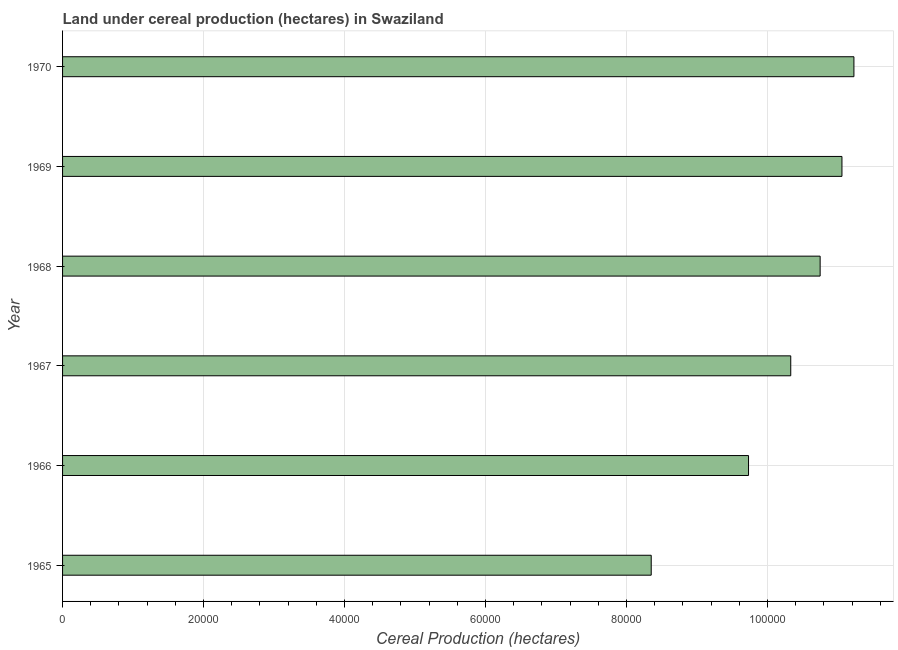Does the graph contain any zero values?
Make the answer very short. No. What is the title of the graph?
Your answer should be very brief. Land under cereal production (hectares) in Swaziland. What is the label or title of the X-axis?
Ensure brevity in your answer.  Cereal Production (hectares). What is the land under cereal production in 1965?
Your answer should be very brief. 8.35e+04. Across all years, what is the maximum land under cereal production?
Offer a terse response. 1.12e+05. Across all years, what is the minimum land under cereal production?
Offer a terse response. 8.35e+04. In which year was the land under cereal production maximum?
Provide a short and direct response. 1970. In which year was the land under cereal production minimum?
Ensure brevity in your answer.  1965. What is the sum of the land under cereal production?
Provide a succinct answer. 6.14e+05. What is the difference between the land under cereal production in 1968 and 1970?
Offer a very short reply. -4792. What is the average land under cereal production per year?
Offer a very short reply. 1.02e+05. What is the median land under cereal production?
Make the answer very short. 1.05e+05. In how many years, is the land under cereal production greater than 68000 hectares?
Your response must be concise. 6. Do a majority of the years between 1965 and 1970 (inclusive) have land under cereal production greater than 56000 hectares?
Offer a terse response. Yes. What is the ratio of the land under cereal production in 1966 to that in 1970?
Provide a succinct answer. 0.87. What is the difference between the highest and the second highest land under cereal production?
Give a very brief answer. 1698. What is the difference between the highest and the lowest land under cereal production?
Your answer should be compact. 2.88e+04. In how many years, is the land under cereal production greater than the average land under cereal production taken over all years?
Your answer should be very brief. 4. How many years are there in the graph?
Your response must be concise. 6. What is the Cereal Production (hectares) of 1965?
Your response must be concise. 8.35e+04. What is the Cereal Production (hectares) of 1966?
Your answer should be compact. 9.73e+04. What is the Cereal Production (hectares) in 1967?
Provide a short and direct response. 1.03e+05. What is the Cereal Production (hectares) in 1968?
Offer a very short reply. 1.07e+05. What is the Cereal Production (hectares) of 1969?
Give a very brief answer. 1.11e+05. What is the Cereal Production (hectares) in 1970?
Your answer should be compact. 1.12e+05. What is the difference between the Cereal Production (hectares) in 1965 and 1966?
Keep it short and to the point. -1.38e+04. What is the difference between the Cereal Production (hectares) in 1965 and 1967?
Make the answer very short. -1.98e+04. What is the difference between the Cereal Production (hectares) in 1965 and 1968?
Provide a succinct answer. -2.40e+04. What is the difference between the Cereal Production (hectares) in 1965 and 1969?
Provide a succinct answer. -2.71e+04. What is the difference between the Cereal Production (hectares) in 1965 and 1970?
Make the answer very short. -2.88e+04. What is the difference between the Cereal Production (hectares) in 1966 and 1967?
Provide a succinct answer. -5987. What is the difference between the Cereal Production (hectares) in 1966 and 1968?
Ensure brevity in your answer.  -1.02e+04. What is the difference between the Cereal Production (hectares) in 1966 and 1969?
Give a very brief answer. -1.33e+04. What is the difference between the Cereal Production (hectares) in 1966 and 1970?
Provide a short and direct response. -1.50e+04. What is the difference between the Cereal Production (hectares) in 1967 and 1968?
Keep it short and to the point. -4171. What is the difference between the Cereal Production (hectares) in 1967 and 1969?
Make the answer very short. -7265. What is the difference between the Cereal Production (hectares) in 1967 and 1970?
Your answer should be compact. -8963. What is the difference between the Cereal Production (hectares) in 1968 and 1969?
Your response must be concise. -3094. What is the difference between the Cereal Production (hectares) in 1968 and 1970?
Ensure brevity in your answer.  -4792. What is the difference between the Cereal Production (hectares) in 1969 and 1970?
Your answer should be very brief. -1698. What is the ratio of the Cereal Production (hectares) in 1965 to that in 1966?
Ensure brevity in your answer.  0.86. What is the ratio of the Cereal Production (hectares) in 1965 to that in 1967?
Ensure brevity in your answer.  0.81. What is the ratio of the Cereal Production (hectares) in 1965 to that in 1968?
Ensure brevity in your answer.  0.78. What is the ratio of the Cereal Production (hectares) in 1965 to that in 1969?
Your answer should be very brief. 0.76. What is the ratio of the Cereal Production (hectares) in 1965 to that in 1970?
Keep it short and to the point. 0.74. What is the ratio of the Cereal Production (hectares) in 1966 to that in 1967?
Your answer should be very brief. 0.94. What is the ratio of the Cereal Production (hectares) in 1966 to that in 1968?
Give a very brief answer. 0.91. What is the ratio of the Cereal Production (hectares) in 1966 to that in 1969?
Your answer should be compact. 0.88. What is the ratio of the Cereal Production (hectares) in 1966 to that in 1970?
Your answer should be very brief. 0.87. What is the ratio of the Cereal Production (hectares) in 1967 to that in 1969?
Offer a terse response. 0.93. What is the ratio of the Cereal Production (hectares) in 1968 to that in 1969?
Offer a very short reply. 0.97. What is the ratio of the Cereal Production (hectares) in 1968 to that in 1970?
Provide a short and direct response. 0.96. What is the ratio of the Cereal Production (hectares) in 1969 to that in 1970?
Your response must be concise. 0.98. 